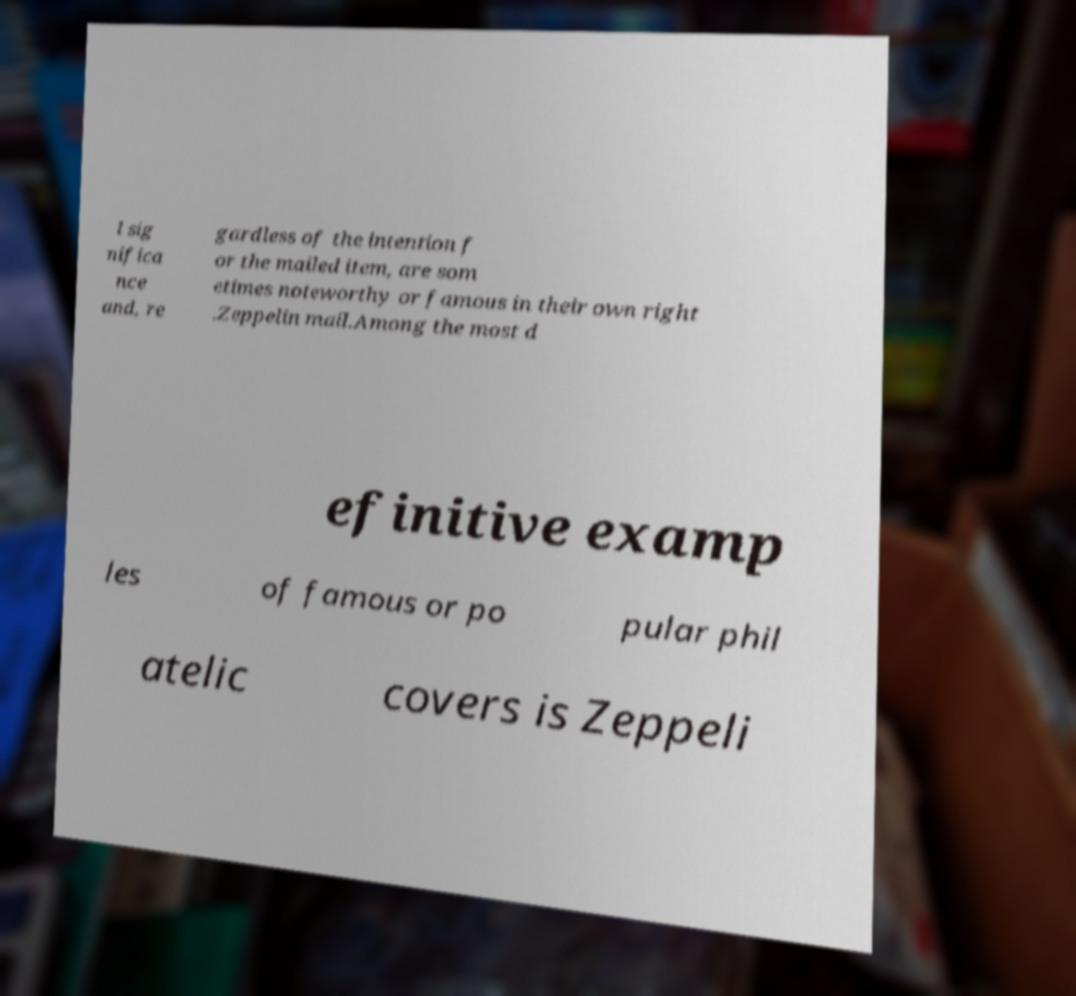Could you assist in decoding the text presented in this image and type it out clearly? l sig nifica nce and, re gardless of the intention f or the mailed item, are som etimes noteworthy or famous in their own right .Zeppelin mail.Among the most d efinitive examp les of famous or po pular phil atelic covers is Zeppeli 